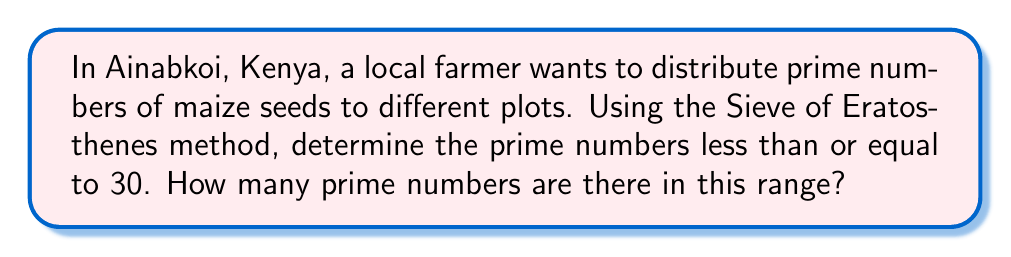Show me your answer to this math problem. Let's apply the Sieve of Eratosthenes method to find prime numbers up to 30:

1) First, list all numbers from 2 to 30:
   2, 3, 4, 5, 6, 7, 8, 9, 10, 11, 12, 13, 14, 15, 16, 17, 18, 19, 20, 21, 22, 23, 24, 25, 26, 27, 28, 29, 30

2) The first number, 2, is prime. Mark all multiples of 2 (except 2 itself):
   2, 3, $\cancel{4}$, 5, $\cancel{6}$, 7, $\cancel{8}$, 9, $\cancel{10}$, 11, $\cancel{12}$, 13, $\cancel{14}$, 15, $\cancel{16}$, 17, $\cancel{18}$, 19, $\cancel{20}$, 21, $\cancel{22}$, 23, $\cancel{24}$, 25, $\cancel{26}$, 27, $\cancel{28}$, 29, $\cancel{30}$

3) The next unmarked number is 3. It's prime. Mark all its multiples (except 3):
   2, 3, $\cancel{4}$, 5, $\cancel{6}$, 7, $\cancel{8}$, $\cancel{9}$, $\cancel{10}$, 11, $\cancel{12}$, 13, $\cancel{14}$, $\cancel{15}$, $\cancel{16}$, 17, $\cancel{18}$, 19, $\cancel{20}$, $\cancel{21}$, $\cancel{22}$, 23, $\cancel{24}$, 25, $\cancel{26}$, $\cancel{27}$, $\cancel{28}$, 29, $\cancel{30}$

4) The next unmarked number is 5. Mark its multiples:
   2, 3, $\cancel{4}$, 5, $\cancel{6}$, 7, $\cancel{8}$, $\cancel{9}$, $\cancel{10}$, 11, $\cancel{12}$, 13, $\cancel{14}$, $\cancel{15}$, $\cancel{16}$, 17, $\cancel{18}$, 19, $\cancel{20}$, $\cancel{21}$, $\cancel{22}$, 23, $\cancel{24}$, $\cancel{25}$, $\cancel{26}$, $\cancel{27}$, $\cancel{28}$, 29, $\cancel{30}$

5) The next unmarked number is 7. Its first multiple greater than 7 is 49, which is beyond our range.

6) All remaining unmarked numbers are prime.

The prime numbers less than or equal to 30 are:
2, 3, 5, 7, 11, 13, 17, 19, 23, 29

Counting these numbers, we find that there are 10 prime numbers in this range.
Answer: 10 